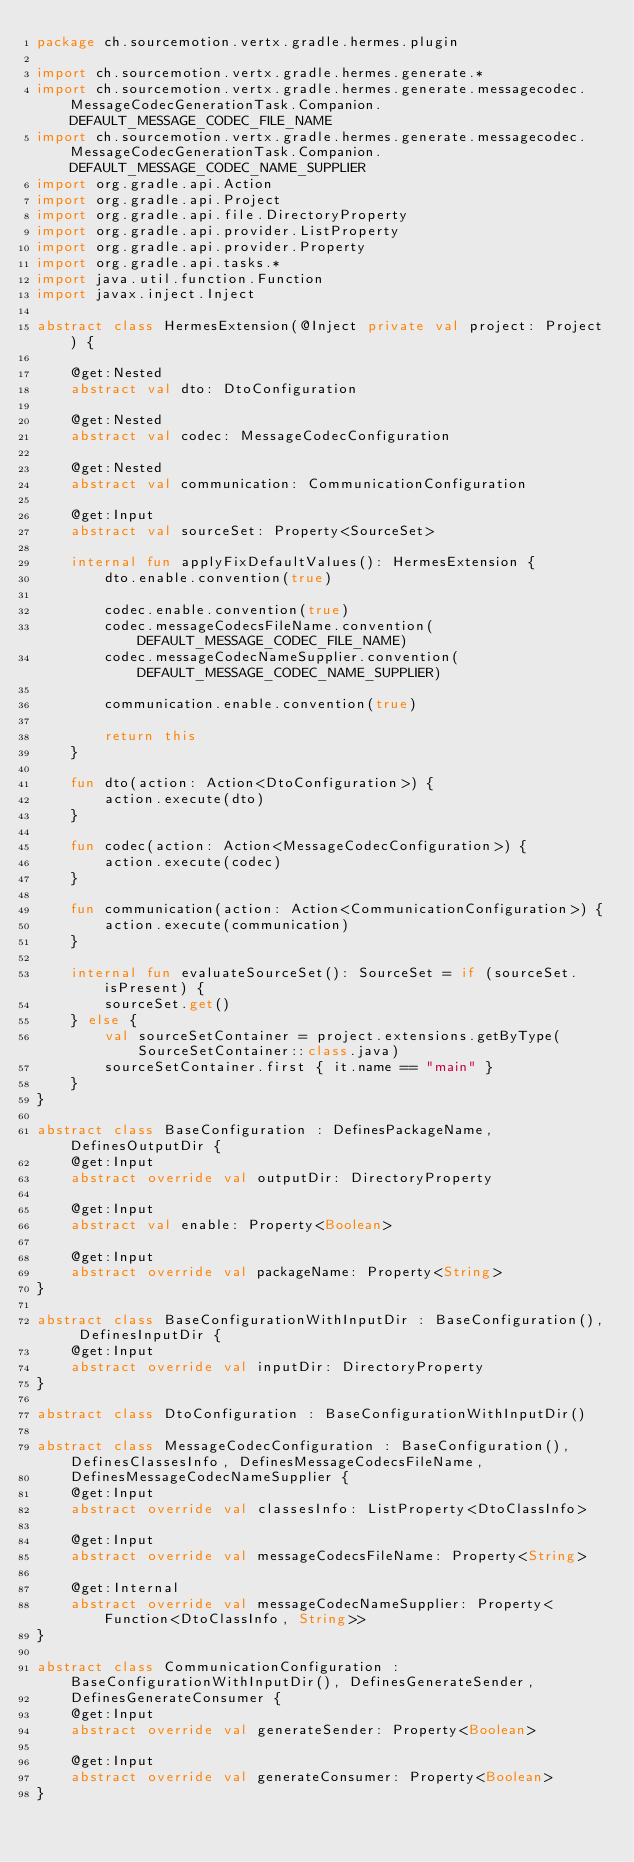<code> <loc_0><loc_0><loc_500><loc_500><_Kotlin_>package ch.sourcemotion.vertx.gradle.hermes.plugin

import ch.sourcemotion.vertx.gradle.hermes.generate.*
import ch.sourcemotion.vertx.gradle.hermes.generate.messagecodec.MessageCodecGenerationTask.Companion.DEFAULT_MESSAGE_CODEC_FILE_NAME
import ch.sourcemotion.vertx.gradle.hermes.generate.messagecodec.MessageCodecGenerationTask.Companion.DEFAULT_MESSAGE_CODEC_NAME_SUPPLIER
import org.gradle.api.Action
import org.gradle.api.Project
import org.gradle.api.file.DirectoryProperty
import org.gradle.api.provider.ListProperty
import org.gradle.api.provider.Property
import org.gradle.api.tasks.*
import java.util.function.Function
import javax.inject.Inject

abstract class HermesExtension(@Inject private val project: Project) {

    @get:Nested
    abstract val dto: DtoConfiguration

    @get:Nested
    abstract val codec: MessageCodecConfiguration

    @get:Nested
    abstract val communication: CommunicationConfiguration

    @get:Input
    abstract val sourceSet: Property<SourceSet>

    internal fun applyFixDefaultValues(): HermesExtension {
        dto.enable.convention(true)

        codec.enable.convention(true)
        codec.messageCodecsFileName.convention(DEFAULT_MESSAGE_CODEC_FILE_NAME)
        codec.messageCodecNameSupplier.convention(DEFAULT_MESSAGE_CODEC_NAME_SUPPLIER)

        communication.enable.convention(true)

        return this
    }

    fun dto(action: Action<DtoConfiguration>) {
        action.execute(dto)
    }

    fun codec(action: Action<MessageCodecConfiguration>) {
        action.execute(codec)
    }

    fun communication(action: Action<CommunicationConfiguration>) {
        action.execute(communication)
    }

    internal fun evaluateSourceSet(): SourceSet = if (sourceSet.isPresent) {
        sourceSet.get()
    } else {
        val sourceSetContainer = project.extensions.getByType(SourceSetContainer::class.java)
        sourceSetContainer.first { it.name == "main" }
    }
}

abstract class BaseConfiguration : DefinesPackageName, DefinesOutputDir {
    @get:Input
    abstract override val outputDir: DirectoryProperty

    @get:Input
    abstract val enable: Property<Boolean>

    @get:Input
    abstract override val packageName: Property<String>
}

abstract class BaseConfigurationWithInputDir : BaseConfiguration(), DefinesInputDir {
    @get:Input
    abstract override val inputDir: DirectoryProperty
}

abstract class DtoConfiguration : BaseConfigurationWithInputDir()

abstract class MessageCodecConfiguration : BaseConfiguration(), DefinesClassesInfo, DefinesMessageCodecsFileName,
    DefinesMessageCodecNameSupplier {
    @get:Input
    abstract override val classesInfo: ListProperty<DtoClassInfo>

    @get:Input
    abstract override val messageCodecsFileName: Property<String>

    @get:Internal
    abstract override val messageCodecNameSupplier: Property<Function<DtoClassInfo, String>>
}

abstract class CommunicationConfiguration : BaseConfigurationWithInputDir(), DefinesGenerateSender,
    DefinesGenerateConsumer {
    @get:Input
    abstract override val generateSender: Property<Boolean>

    @get:Input
    abstract override val generateConsumer: Property<Boolean>
}</code> 